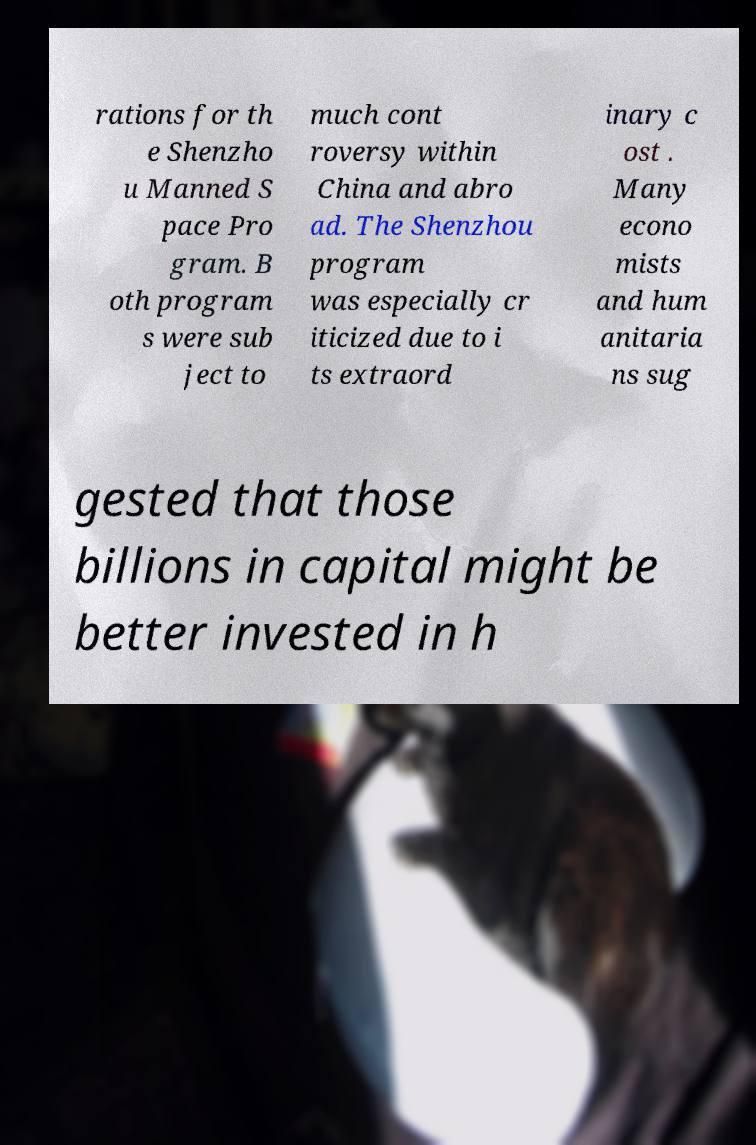Can you read and provide the text displayed in the image?This photo seems to have some interesting text. Can you extract and type it out for me? rations for th e Shenzho u Manned S pace Pro gram. B oth program s were sub ject to much cont roversy within China and abro ad. The Shenzhou program was especially cr iticized due to i ts extraord inary c ost . Many econo mists and hum anitaria ns sug gested that those billions in capital might be better invested in h 